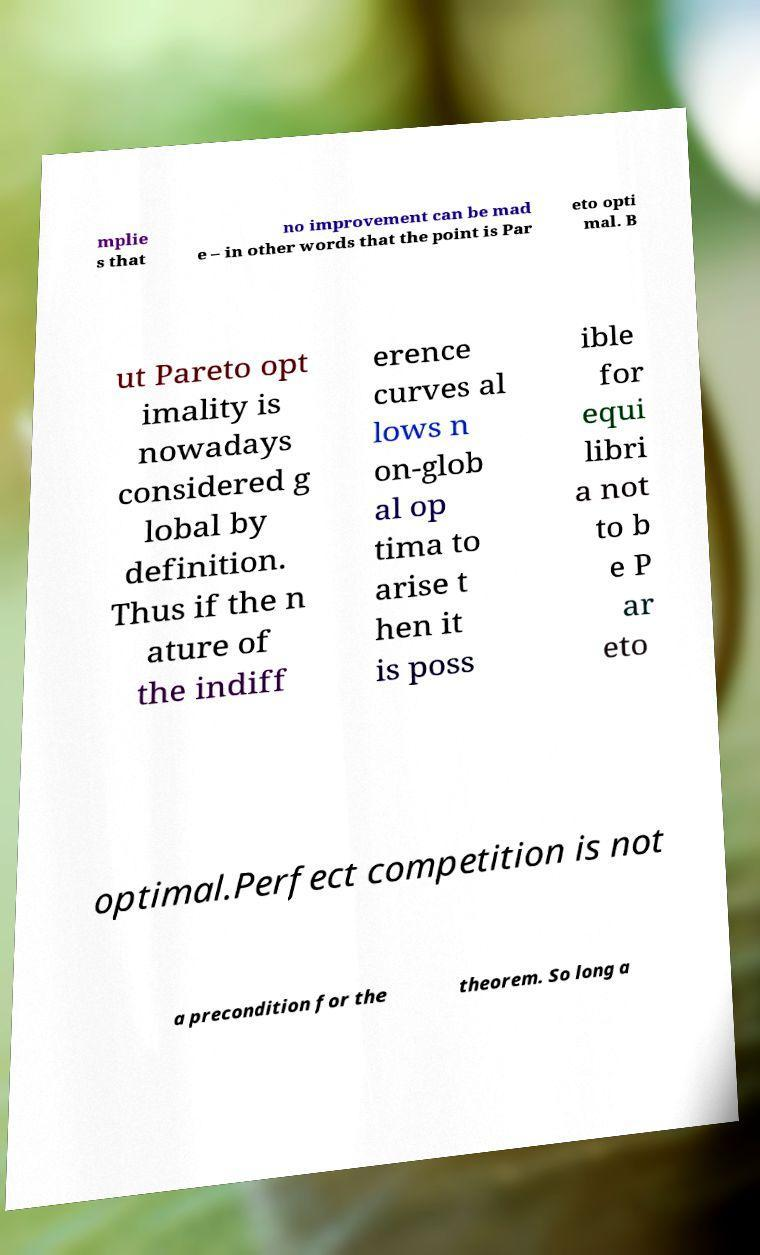Could you extract and type out the text from this image? mplie s that no improvement can be mad e – in other words that the point is Par eto opti mal. B ut Pareto opt imality is nowadays considered g lobal by definition. Thus if the n ature of the indiff erence curves al lows n on-glob al op tima to arise t hen it is poss ible for equi libri a not to b e P ar eto optimal.Perfect competition is not a precondition for the theorem. So long a 